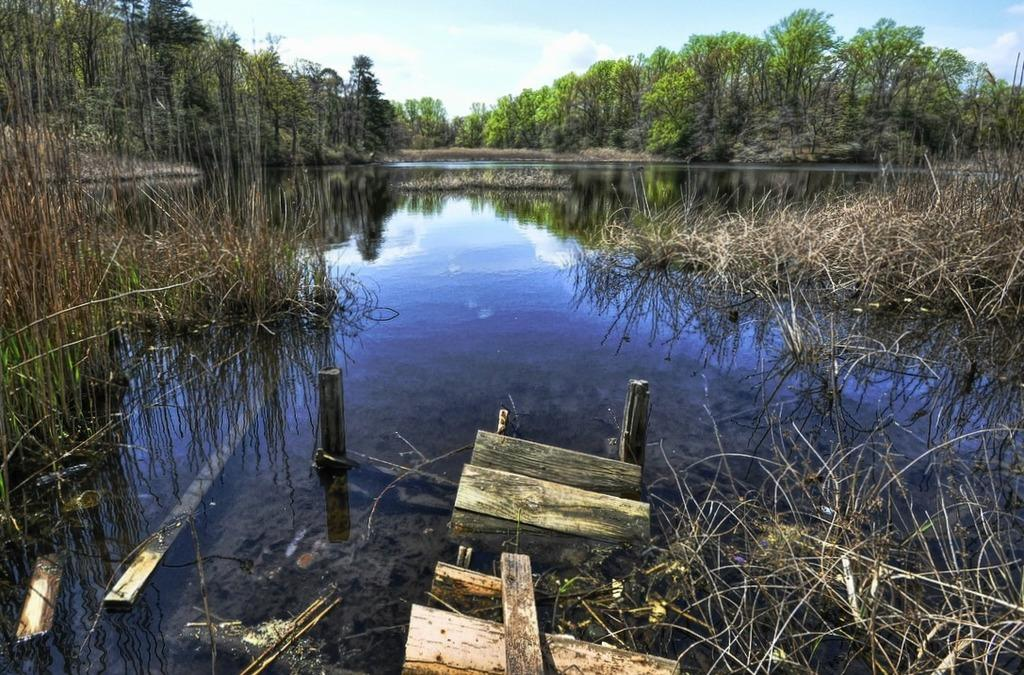What type of vegetation can be seen in the image? There are green trees in the image. What natural element is visible in the image? There is water visible in the image. What type of ground cover is present in the image? Dry grass is present in the image. What type of material is used for the objects in the image? There are wooden objects in the image. What type of structures are present in the image? There are poles in the image. What is the color of the sky in the image? The sky is blue and white in color. How does the image increase in size over time? The image does not increase in size over time; it is a static image. What type of pin is used to hold the trees in place in the image? There are no pins present in the image; the trees are not held in place by any visible means. 